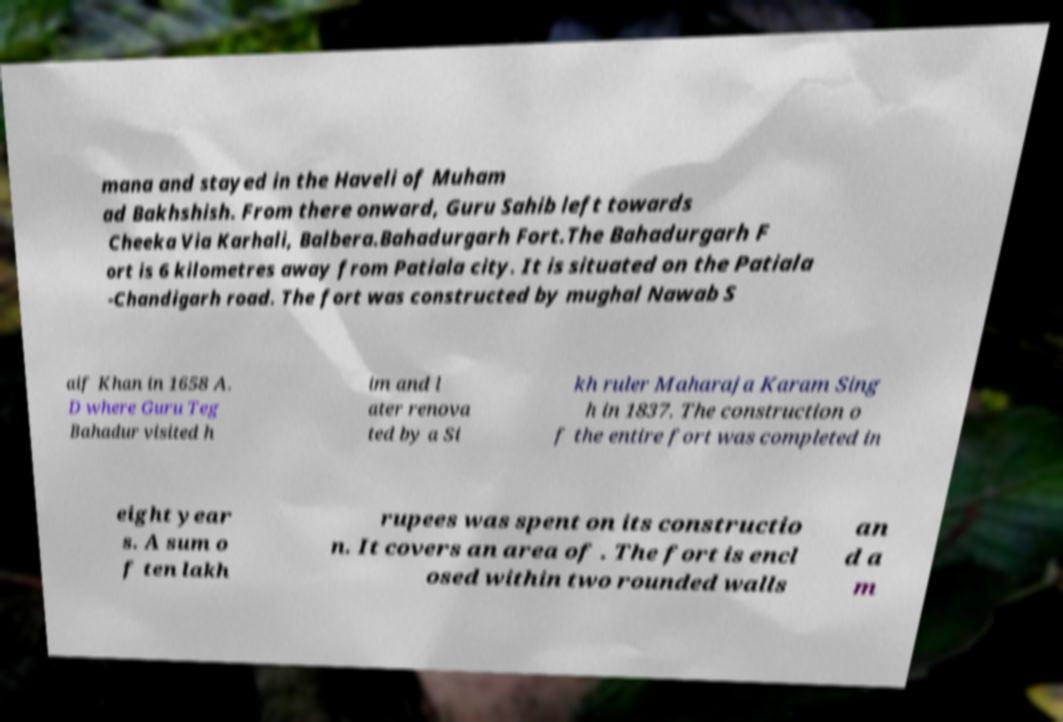Can you read and provide the text displayed in the image?This photo seems to have some interesting text. Can you extract and type it out for me? mana and stayed in the Haveli of Muham ad Bakhshish. From there onward, Guru Sahib left towards Cheeka Via Karhali, Balbera.Bahadurgarh Fort.The Bahadurgarh F ort is 6 kilometres away from Patiala city. It is situated on the Patiala -Chandigarh road. The fort was constructed by mughal Nawab S aif Khan in 1658 A. D where Guru Teg Bahadur visited h im and l ater renova ted by a Si kh ruler Maharaja Karam Sing h in 1837. The construction o f the entire fort was completed in eight year s. A sum o f ten lakh rupees was spent on its constructio n. It covers an area of . The fort is encl osed within two rounded walls an d a m 